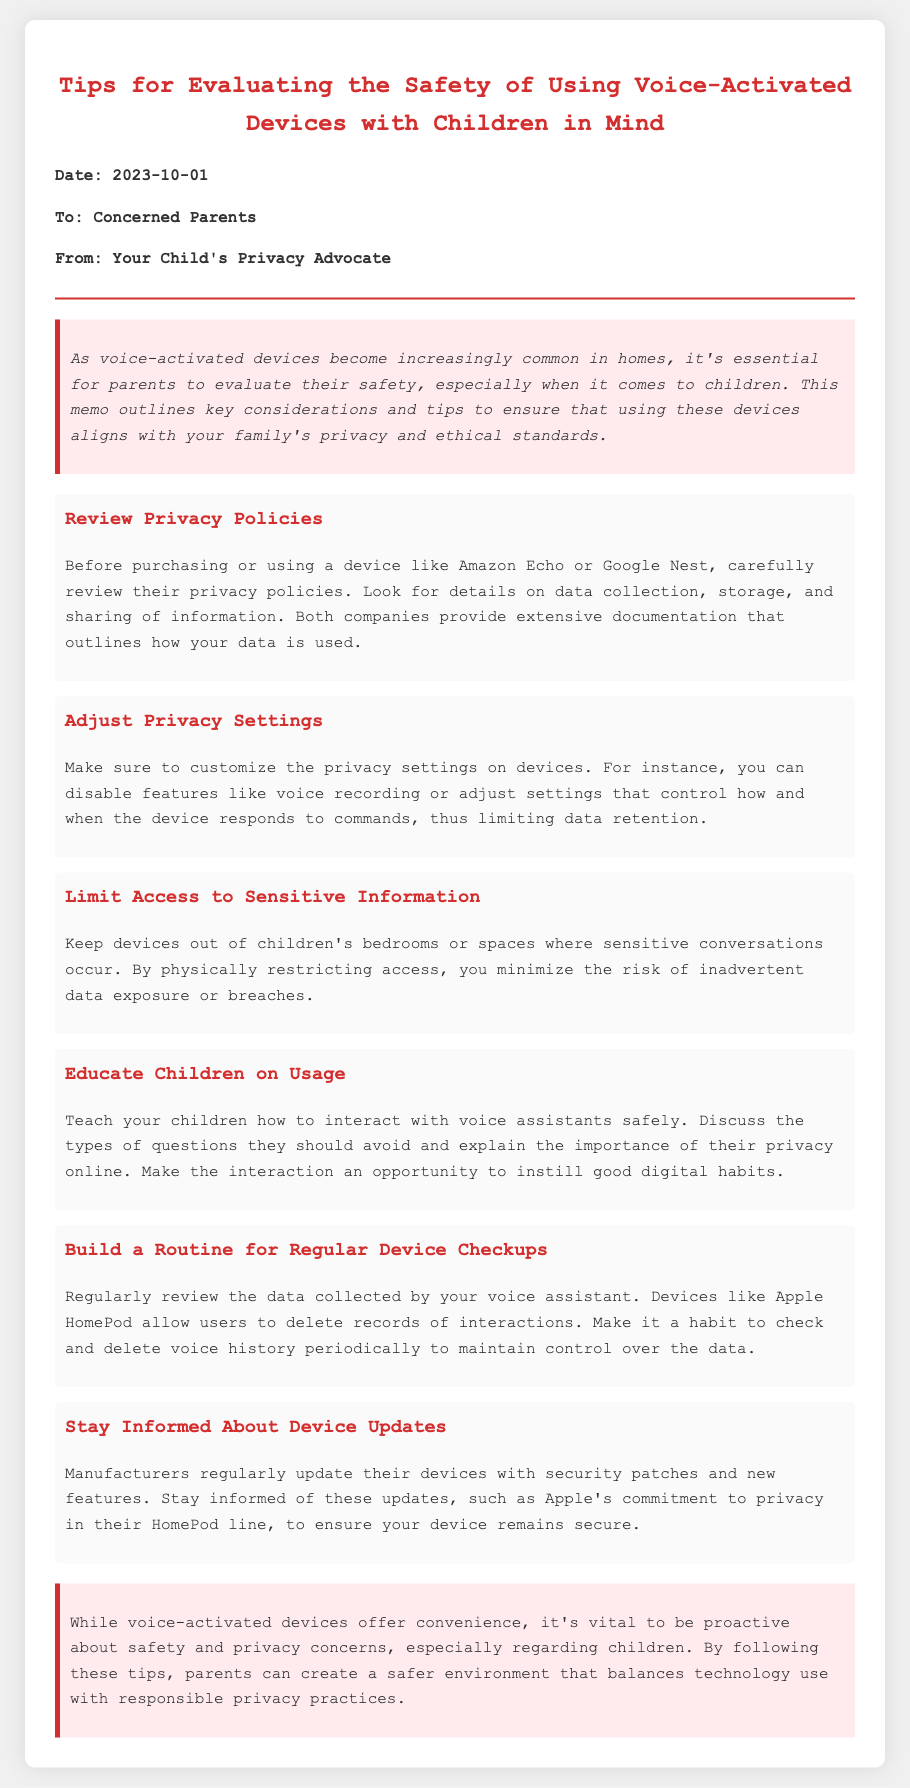What is the title of the memo? The title of the memo is found in the header section, summarizing the content regarding voice assistants and children's safety.
Answer: Tips for Evaluating the Safety of Using Voice-Activated Devices with Children in Mind Who is the memorandum intended for? The intended audience of the memo is located in the "To" section, identifying the specific group addressed.
Answer: Concerned Parents When was the memo published? The publication date is specified in the "Date" section, providing the exact release information.
Answer: 2023-10-01 How many tips are provided in the memo? The number of tips can be counted from the list presented in the document, which outlines specific safety suggestions.
Answer: Six What should be adjusted to enhance privacy? The action to be taken regarding privacy is noted in a tip that specifically discusses changing device settings.
Answer: Privacy Settings What is one way to limit access to sensitive information? The memo provides a specific recommendation in one of its tips regarding where to place devices in relation to children.
Answer: Keep devices out of children's bedrooms What does the memo suggest parents educate children about? The document emphasizes the importance of informing children about safe interaction with technology and responsible use, according to one of the tips.
Answer: Interacting with voice assistants safely What does the conclusion highlight? The memo concludes with a summary of its main point, underscoring the balance between technology use and privacy.
Answer: Proactive about safety and privacy concerns 